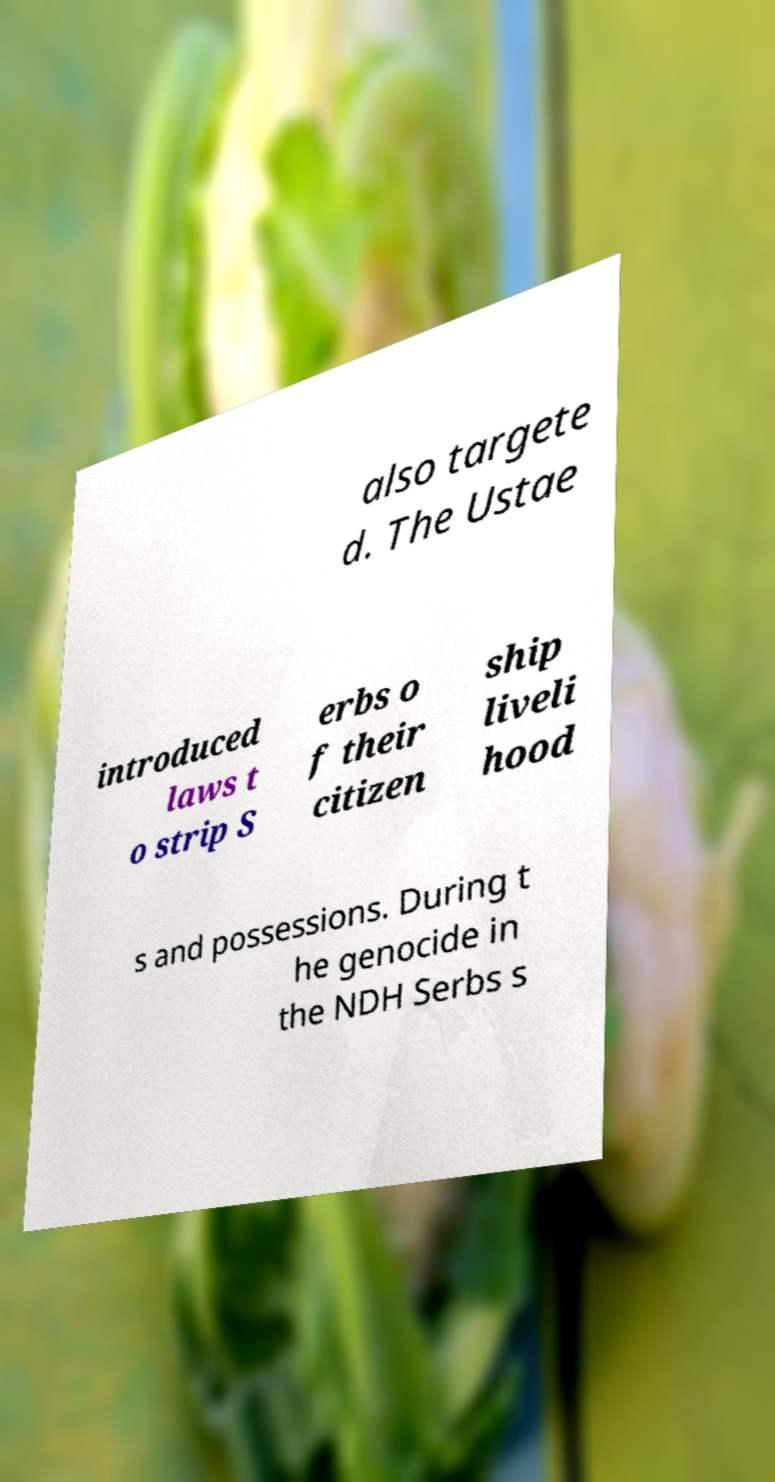Could you assist in decoding the text presented in this image and type it out clearly? also targete d. The Ustae introduced laws t o strip S erbs o f their citizen ship liveli hood s and possessions. During t he genocide in the NDH Serbs s 